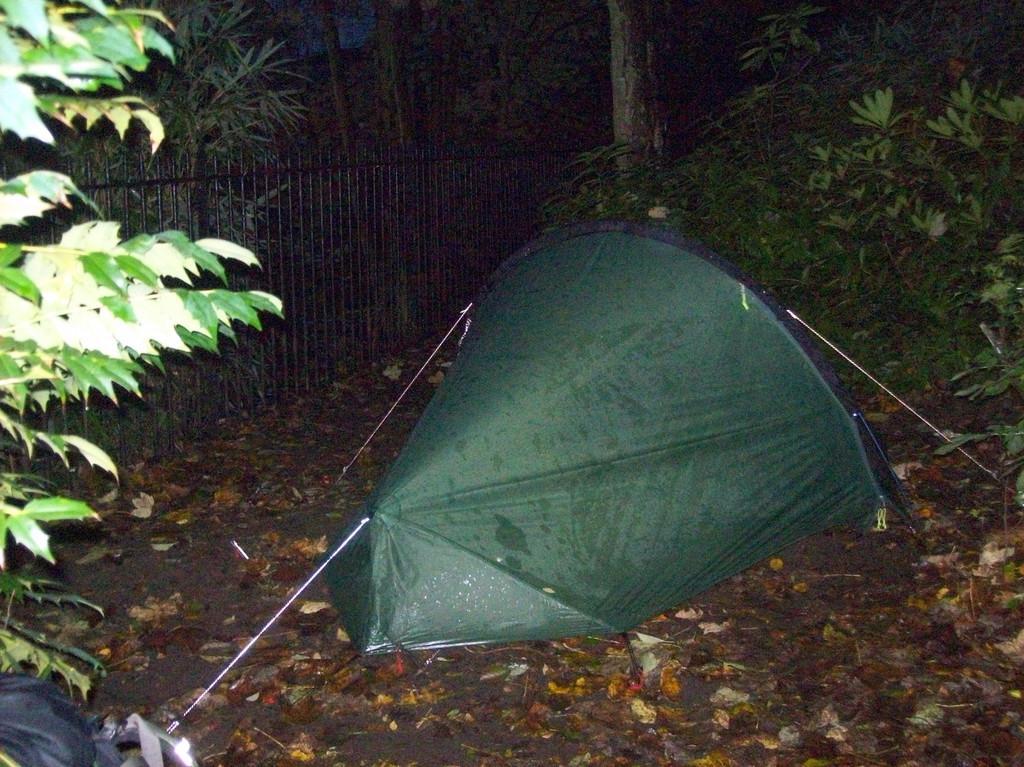Could you give a brief overview of what you see in this image? In this image there is a tent on the ground. Around the tent there are dried leaves on the ground. Behind the text there is a railing. In the background there are trees and plants on the ground. 